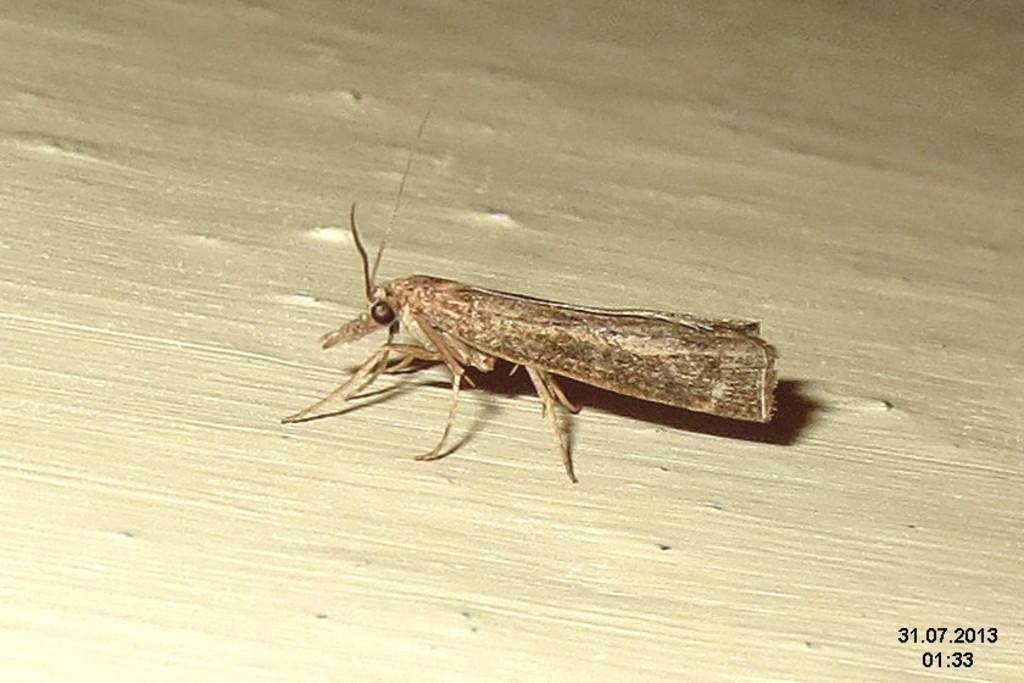Describe this image in one or two sentences. In the foreground of this image, there is an insect which seems like on a wooden surface. 